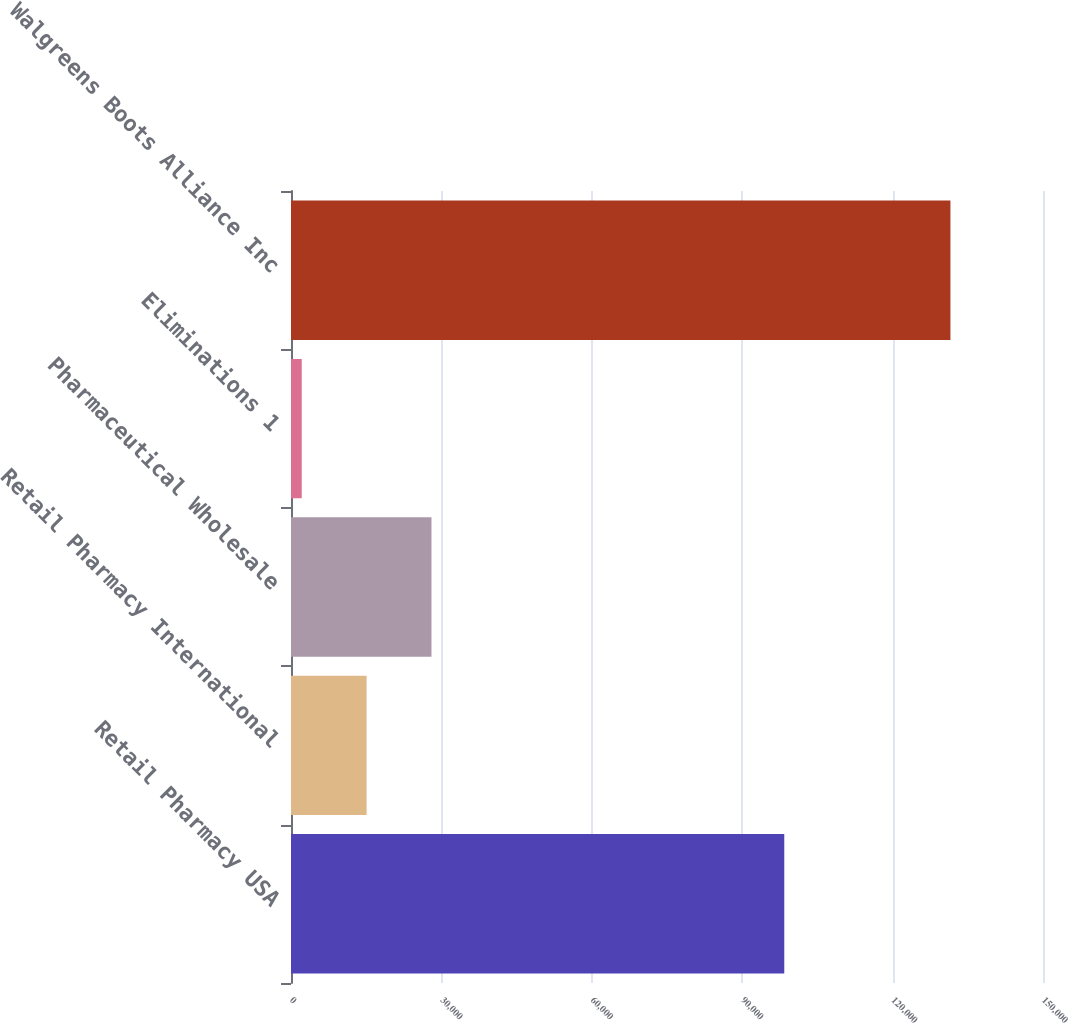Convert chart. <chart><loc_0><loc_0><loc_500><loc_500><bar_chart><fcel>Retail Pharmacy USA<fcel>Retail Pharmacy International<fcel>Pharmaceutical Wholesale<fcel>Eliminations 1<fcel>Walgreens Boots Alliance Inc<nl><fcel>98392<fcel>15081.5<fcel>28021<fcel>2142<fcel>131537<nl></chart> 